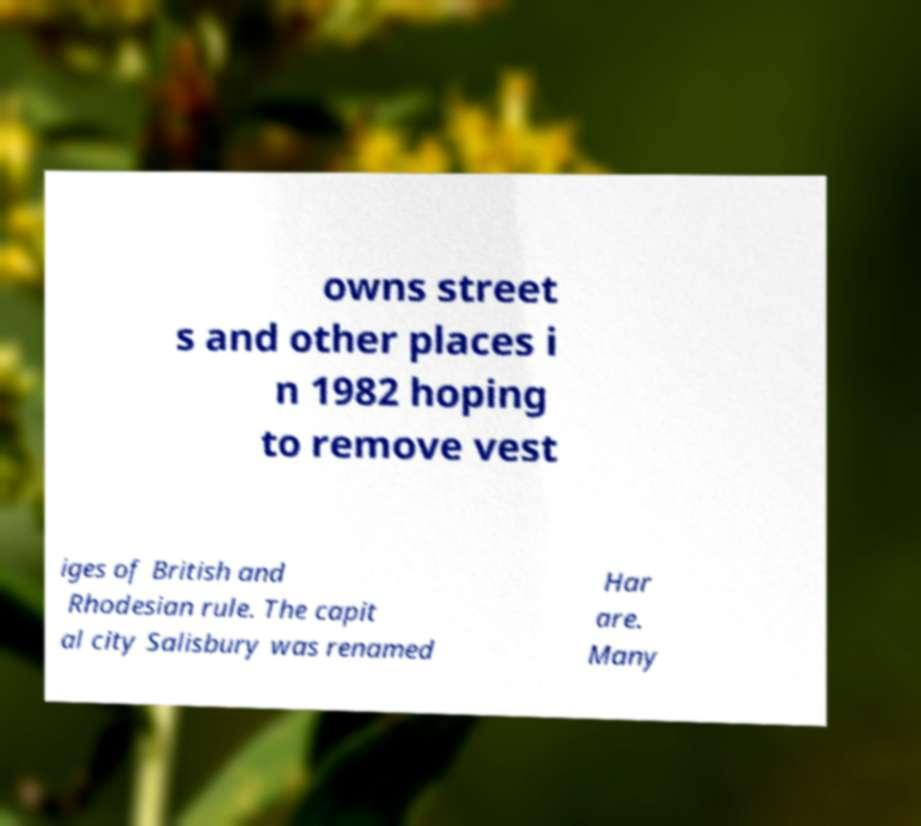Could you extract and type out the text from this image? owns street s and other places i n 1982 hoping to remove vest iges of British and Rhodesian rule. The capit al city Salisbury was renamed Har are. Many 